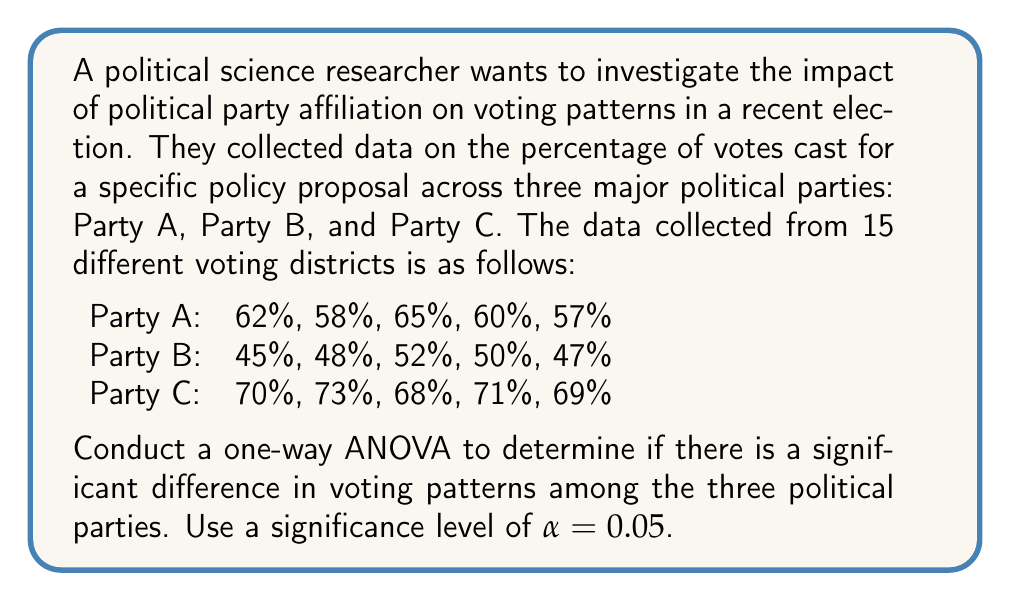Provide a solution to this math problem. To conduct a one-way ANOVA, we'll follow these steps:

1. Calculate the sum of squares between groups (SSB), sum of squares within groups (SSW), and total sum of squares (SST).
2. Calculate the degrees of freedom for between groups (dfB) and within groups (dfW).
3. Calculate the mean squares for between groups (MSB) and within groups (MSW).
4. Calculate the F-statistic.
5. Compare the F-statistic to the critical F-value.

Step 1: Calculate sum of squares

First, we need to calculate the grand mean:
$$\bar{X} = \frac{62 + 58 + 65 + 60 + 57 + 45 + 48 + 52 + 50 + 47 + 70 + 73 + 68 + 71 + 69}{15} = 59.67$$

Now, we can calculate SSB, SSW, and SST:

SSB = $\sum_{i=1}^k n_i(\bar{X_i} - \bar{X})^2$
SSW = $\sum_{i=1}^k \sum_{j=1}^{n_i} (X_{ij} - \bar{X_i})^2$
SST = $\sum_{i=1}^k \sum_{j=1}^{n_i} (X_{ij} - \bar{X})^2$

Where:
$k$ is the number of groups (3 in this case)
$n_i$ is the number of observations in each group (5 in this case)
$\bar{X_i}$ is the mean of each group

Calculating group means:
$\bar{X_A} = 60.4$
$\bar{X_B} = 48.4$
$\bar{X_C} = 70.2$

SSB = $5(60.4 - 59.67)^2 + 5(48.4 - 59.67)^2 + 5(70.2 - 59.67)^2 = 1486.13$

SSW = $[(62-60.4)^2 + (58-60.4)^2 + (65-60.4)^2 + (60-60.4)^2 + (57-60.4)^2] + 
       [(45-48.4)^2 + (48-48.4)^2 + (52-48.4)^2 + (50-48.4)^2 + (47-48.4)^2] +
       [(70-70.2)^2 + (73-70.2)^2 + (68-70.2)^2 + (71-70.2)^2 + (69-70.2)^2]
     = 102.8$

SST = SSB + SSW = 1486.13 + 102.8 = 1588.93

Step 2: Calculate degrees of freedom

dfB = k - 1 = 3 - 1 = 2
dfW = N - k = 15 - 3 = 12
dfT = N - 1 = 15 - 1 = 14

Step 3: Calculate mean squares

MSB = SSB / dfB = 1486.13 / 2 = 743.065
MSW = SSW / dfW = 102.8 / 12 = 8.567

Step 4: Calculate F-statistic

F = MSB / MSW = 743.065 / 8.567 = 86.74

Step 5: Compare F-statistic to critical F-value

The critical F-value for α = 0.05, dfB = 2, and dfW = 12 is approximately 3.89 (from F-distribution table).

Since our calculated F-statistic (86.74) is greater than the critical F-value (3.89), we reject the null hypothesis.
Answer: The one-way ANOVA results show a significant difference in voting patterns among the three political parties (F(2, 12) = 86.74, p < 0.05). We reject the null hypothesis and conclude that political party affiliation has a significant impact on voting patterns for the specific policy proposal. 